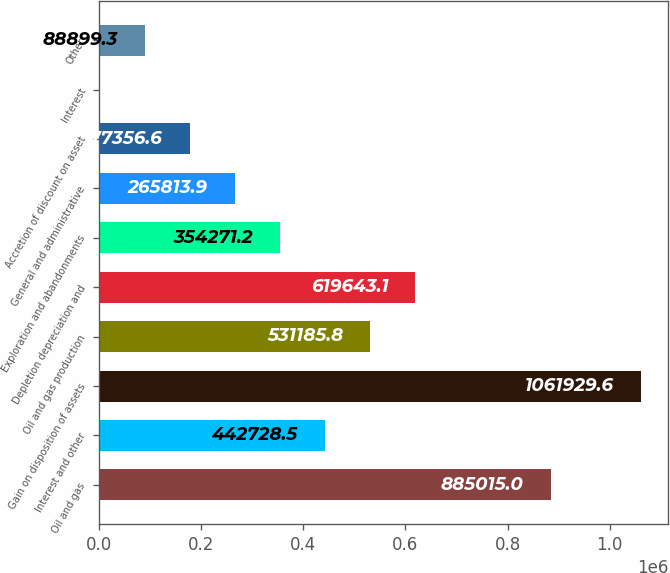Convert chart to OTSL. <chart><loc_0><loc_0><loc_500><loc_500><bar_chart><fcel>Oil and gas<fcel>Interest and other<fcel>Gain on disposition of assets<fcel>Oil and gas production<fcel>Depletion depreciation and<fcel>Exploration and abandonments<fcel>General and administrative<fcel>Accretion of discount on asset<fcel>Interest<fcel>Other<nl><fcel>885015<fcel>442728<fcel>1.06193e+06<fcel>531186<fcel>619643<fcel>354271<fcel>265814<fcel>177357<fcel>442<fcel>88899.3<nl></chart> 